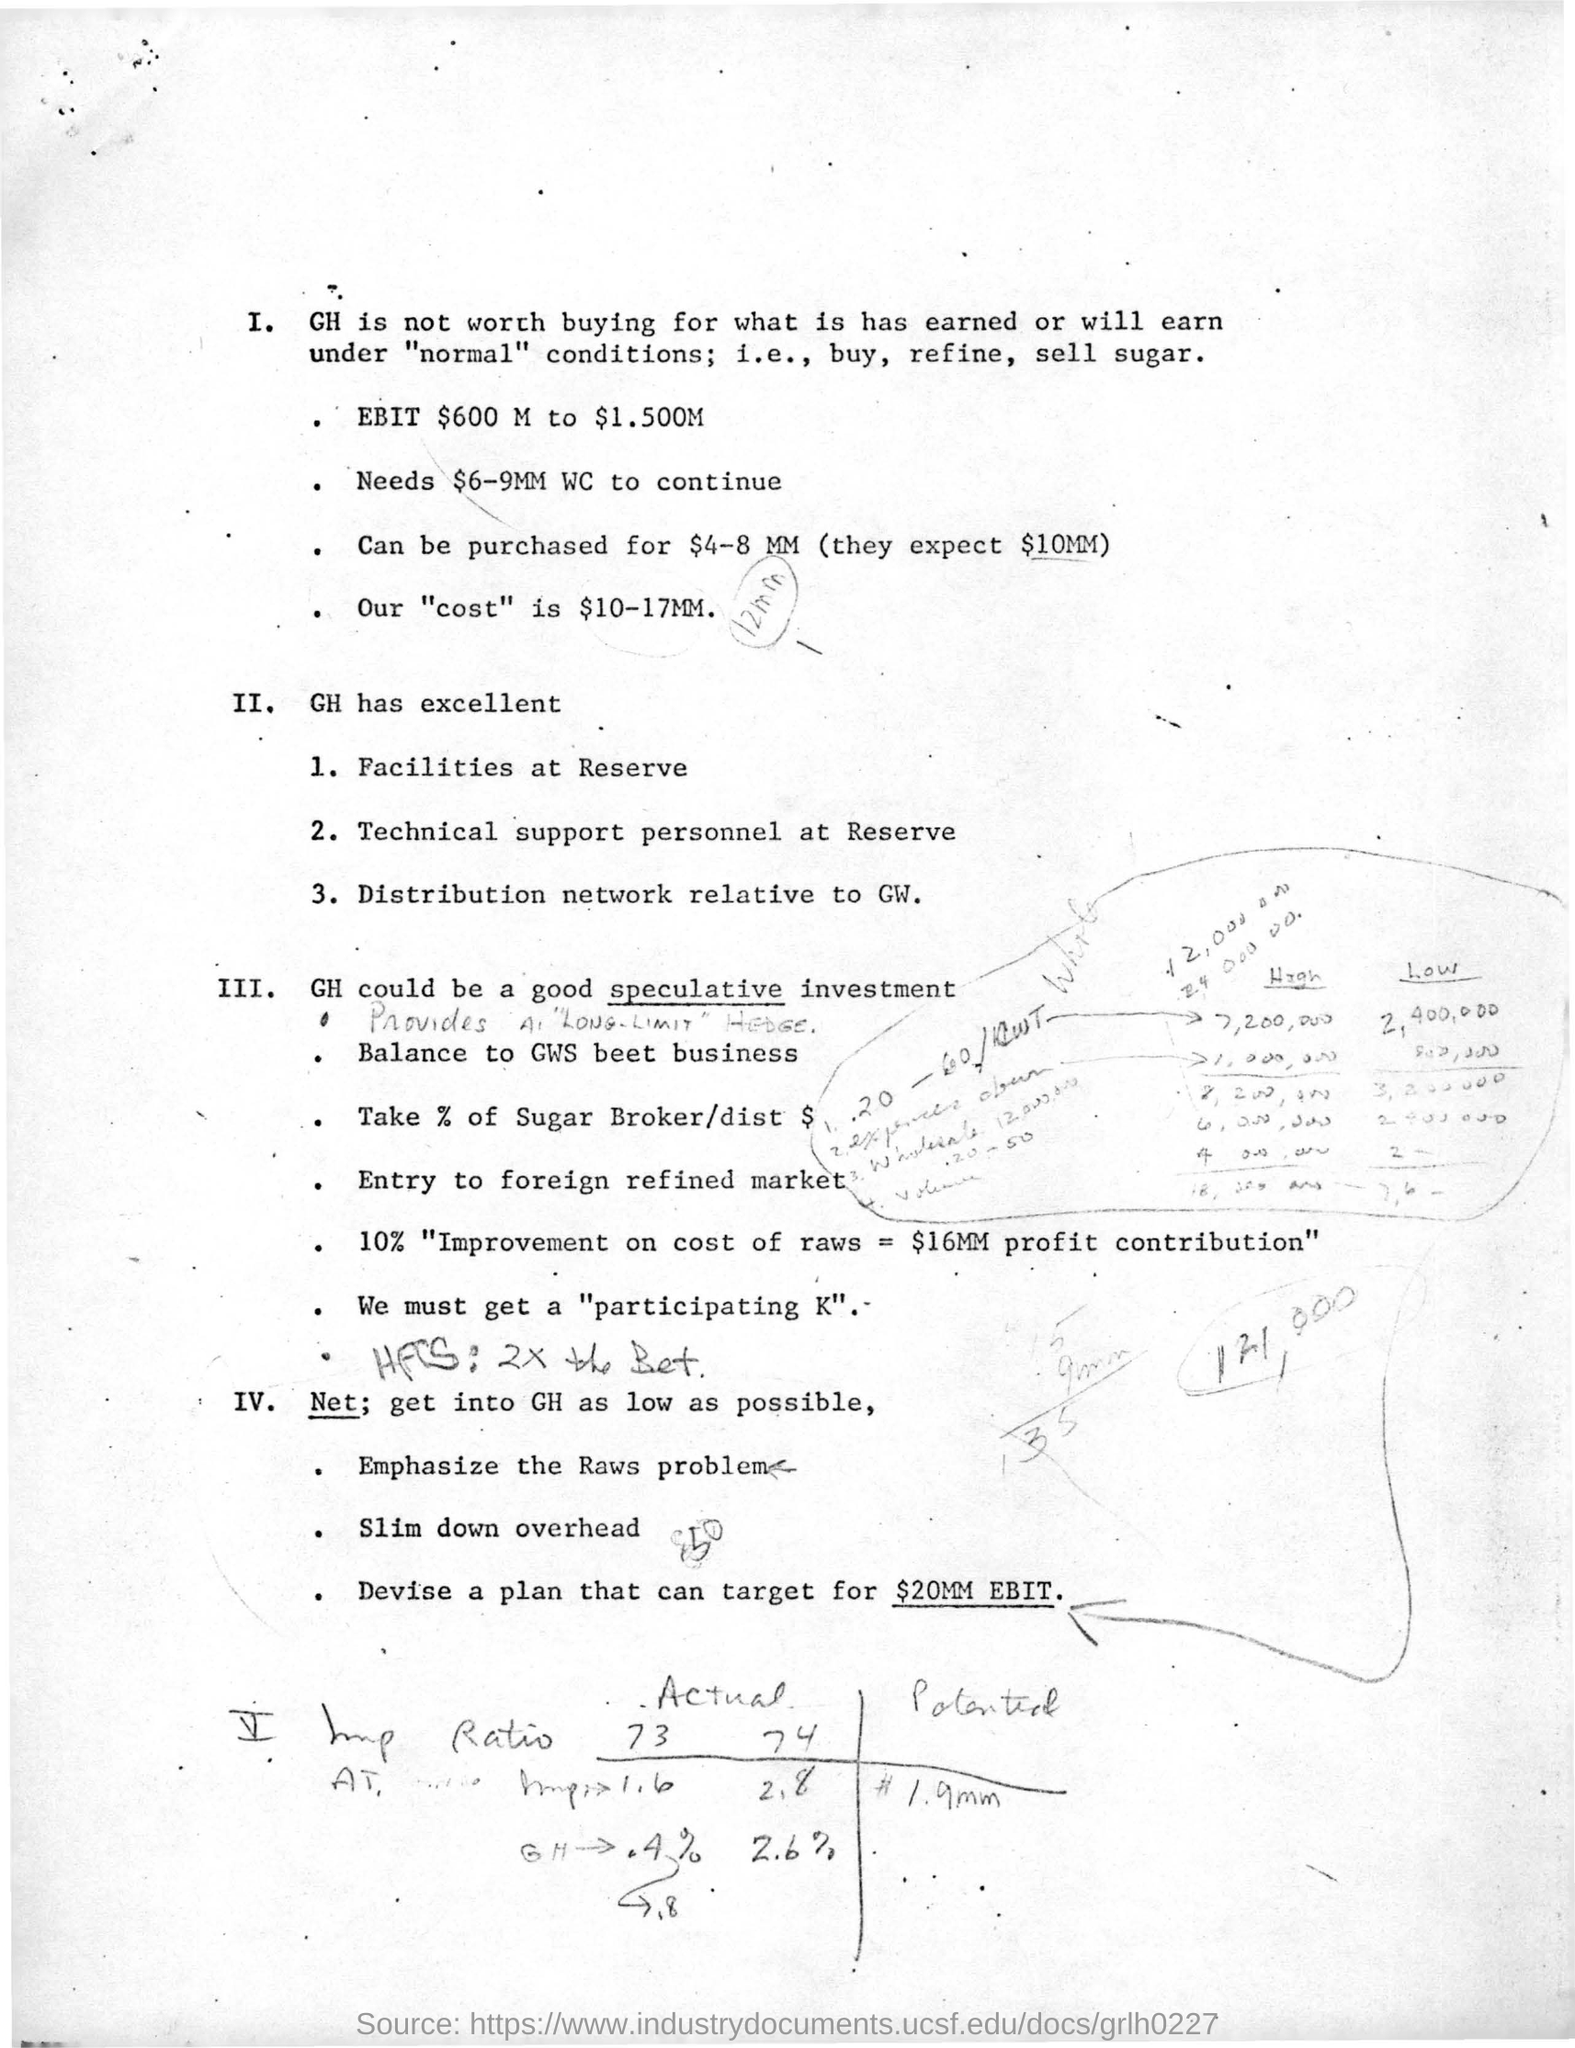What is devise plan target ?
Ensure brevity in your answer.  $20MM EBIT. 